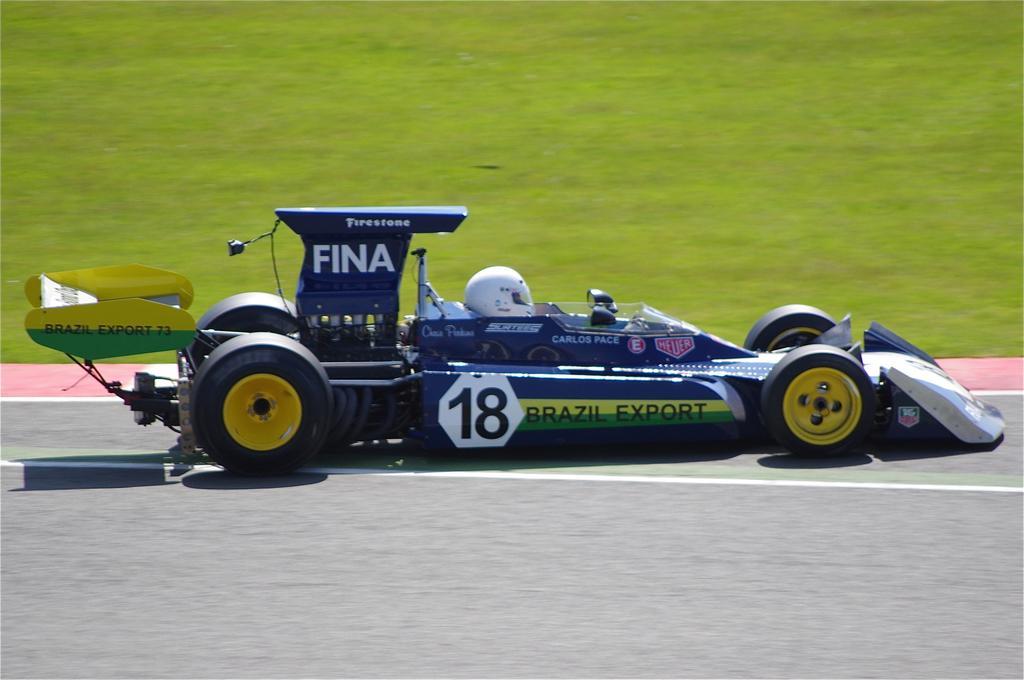Could you give a brief overview of what you see in this image? In this image I see a sports car over here and I see a person sitting and I see something is written on the car and I see the road. In the background I see the grass. 